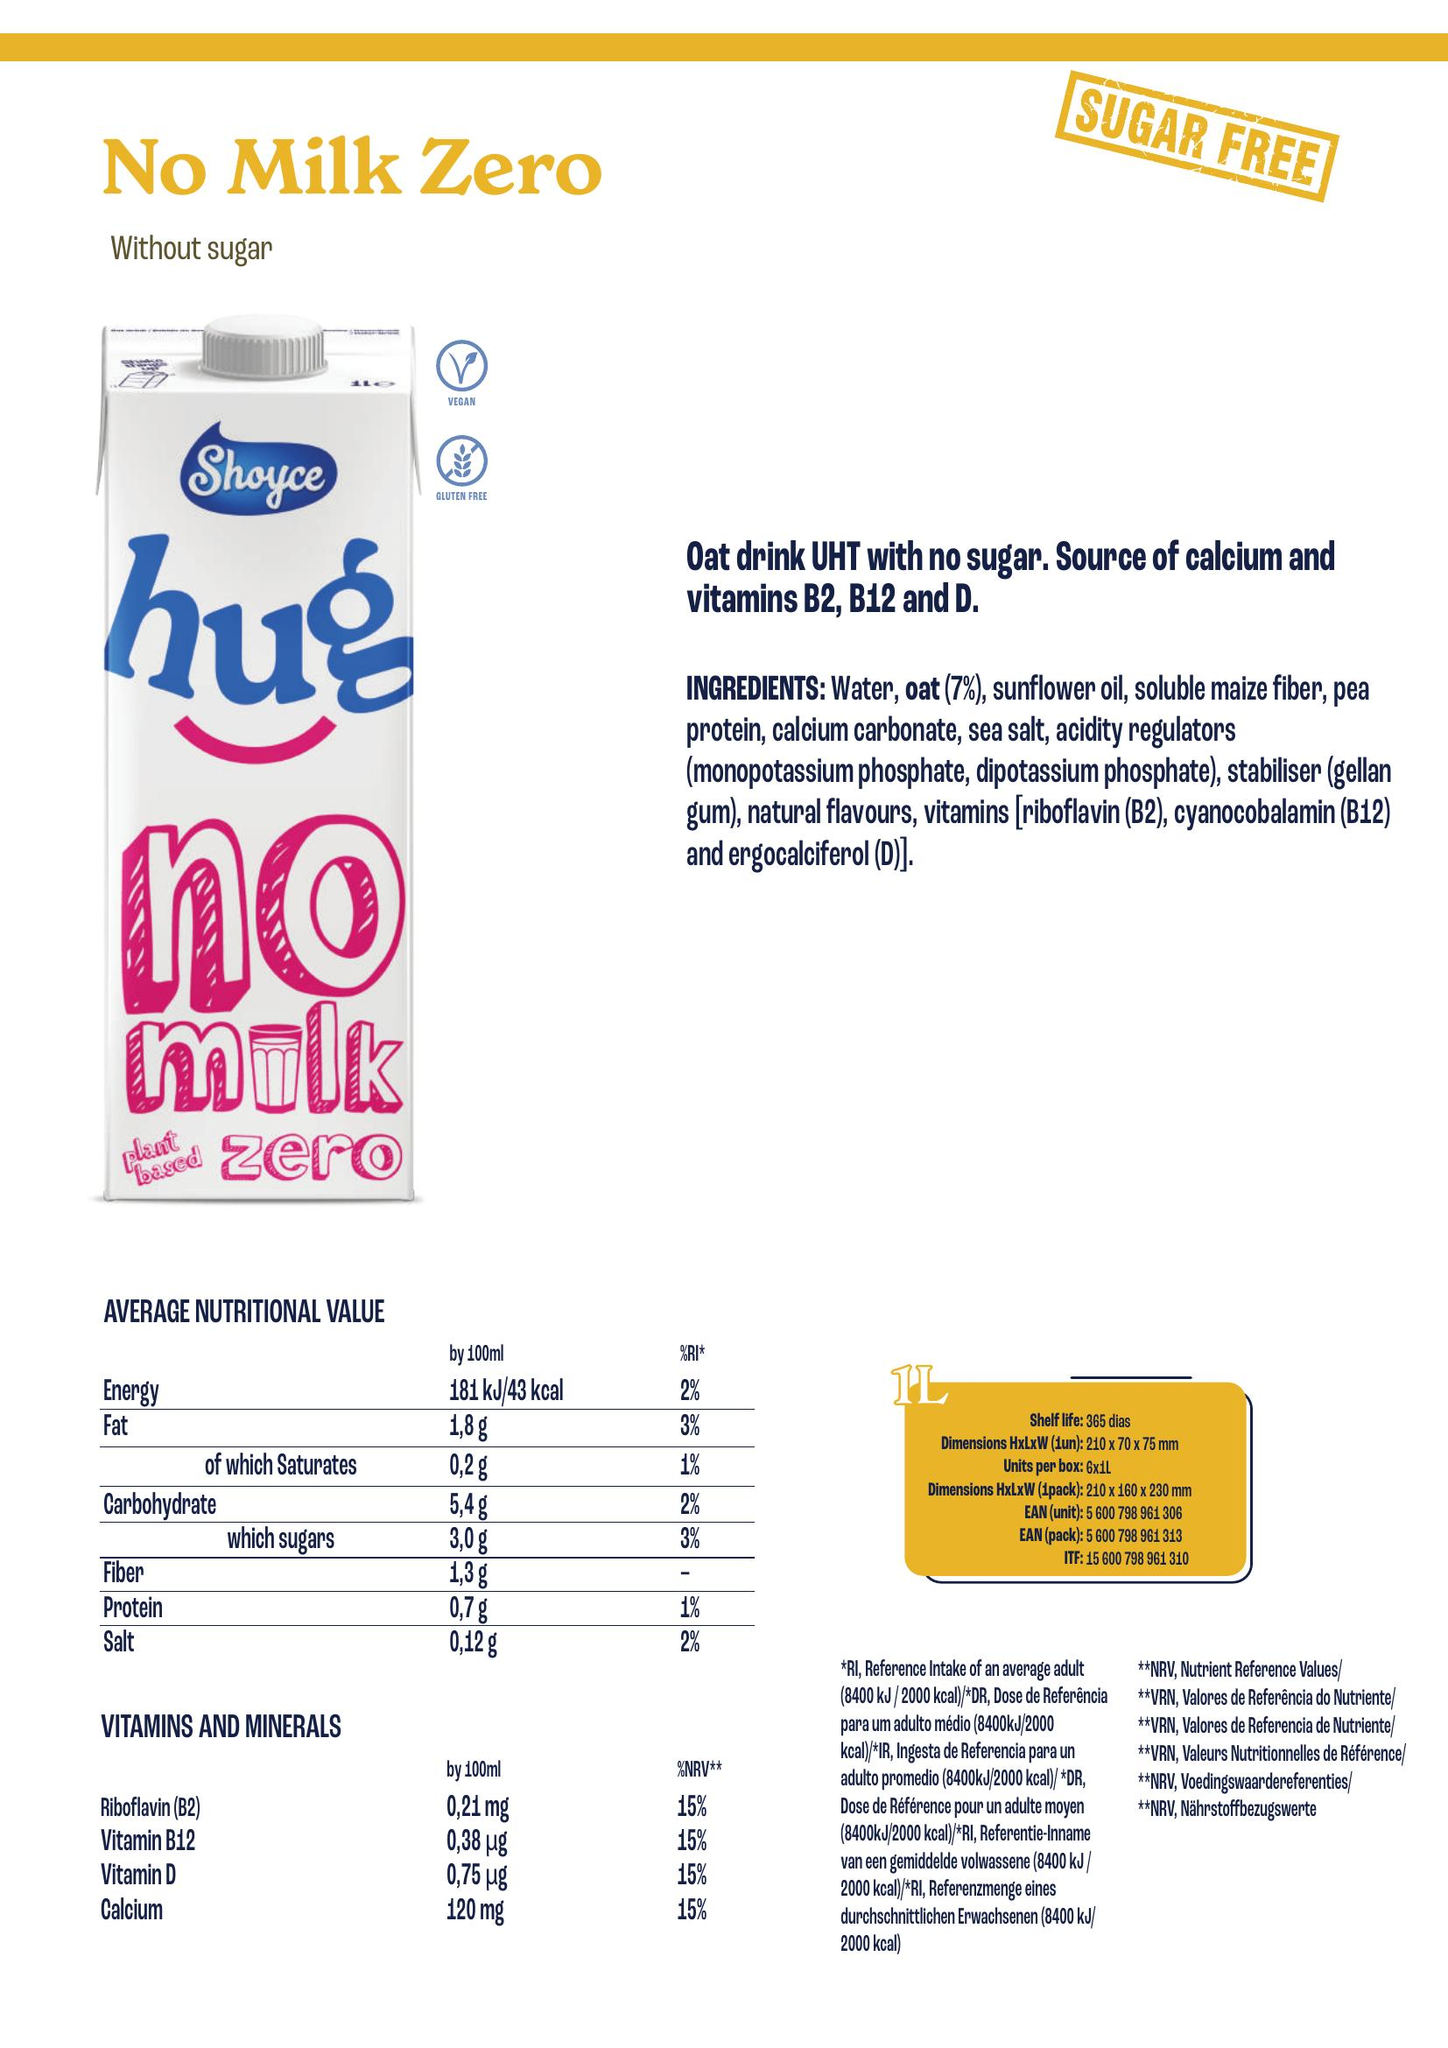From the image, create a nutrition table include as columns the different nutrient present, add the unit associated with the nutrient and append the volume considered for the values in [] after the nutrient name, for energy only consider the information for kcal and isolate the associate value accordingly. Add a column for the product name located in the top left, add a column for the ingredients associated with the product, also add a column for allergens which are ingredients in bold listed in the ingredients.  Write the result as python code to build a dataframe
 Below is the Python code to build a pandas DataFrame from the information provided in the image:

```python
import pandas as pd

# Define the data
data = {
    'Product Name': ['No Milk Zero'],
    'Ingredients': ['Water, oat (7%), sunflower oil, soluble maize fiber, pea protein, calcium carbonate, sea salt, acidity regulators (monopotassium phosphate, dipotassium phosphate), stabiliser (gellan gum), natural flavours, vitamins [riboflavin (B2), cyanocobalamin (B12) and ergocalciferol (D)]'],
    'Allergens': ['None'],
    'Energy [100ml]': ['43 kcal'],
    'Fat [100ml]': ['1.8 g'],
    'of which Saturates [100ml]': ['0.2 g'],
    'Carbohydrate [100ml]': ['5.4 g'],
    'of which sugars [100ml]': ['3.0 g'],
    'Fiber [100ml]': ['1.3 g'],
    'Protein [100ml]': ['0.7 g'],
    'Salt [100ml]': ['0.12 g'],
    'Riboflavin (B2) [100ml]': ['0.21 mg'],
    'Vitamin B12 [100ml]': ['0.38 μg'],
    'Vitamin D [100ml]': ['0.75 μg'],
    'Calcium [100ml]': ['120 mg']
}

# Create DataFrame
df = pd.DataFrame(data)

# Display DataFrame
print(df)
```

This code will create a DataFrame with the nutritional information, product name, ingredients, and allergens for "No Milk Zero" based on the information provided in the image. 